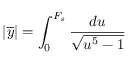Convert formula to latex. <formula><loc_0><loc_0><loc_500><loc_500>| \overline { y } | = \int _ { 0 } ^ { F _ { s } } \frac { d u } { \sqrt { u ^ { 5 } - 1 } }</formula> 